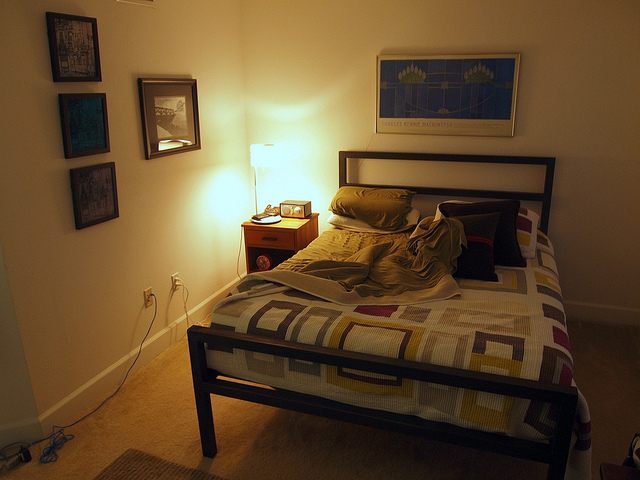<image>What pictures are on the wall? I am not sure what pictures are on the wall. They could be family photos, paintings, or artworks. What is the title on the framed picture? I am not sure what the title on the framed picture is. There are several possibilities like 'walk in park', 'boat', 'love', 'menorahs', 'charles'. What non-fish organisms adorn the beds? I am not sure about the non-fish organisms adorn the beds. It can be seen a dog, humans or none. What pictures are on the wall? I don't know what pictures are on the wall. There can be family photos, framed ones, paintings, or other artworks. What is the title on the framed picture? I am not sure what the title on the framed picture is. Some possible options are 'walk in park', 'picture', 'boat', 'love', 'menorahs', or 'charles'. What non-fish organisms adorn the beds? I am not sure what non-fish organisms adorn the beds. It can be seen 'dog', 'pillows', 'humans' or 'bedding'. 